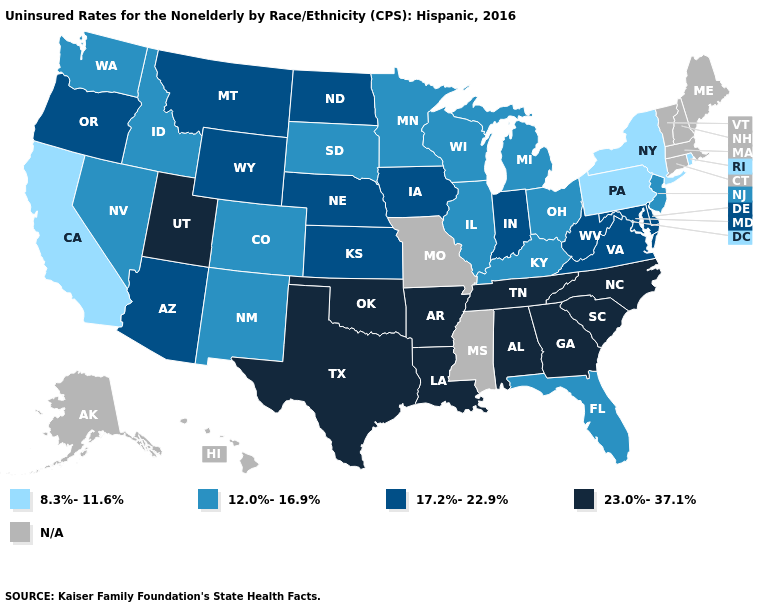Name the states that have a value in the range 23.0%-37.1%?
Answer briefly. Alabama, Arkansas, Georgia, Louisiana, North Carolina, Oklahoma, South Carolina, Tennessee, Texas, Utah. Name the states that have a value in the range 8.3%-11.6%?
Write a very short answer. California, New York, Pennsylvania, Rhode Island. What is the lowest value in states that border Michigan?
Answer briefly. 12.0%-16.9%. Name the states that have a value in the range 17.2%-22.9%?
Concise answer only. Arizona, Delaware, Indiana, Iowa, Kansas, Maryland, Montana, Nebraska, North Dakota, Oregon, Virginia, West Virginia, Wyoming. Name the states that have a value in the range 12.0%-16.9%?
Give a very brief answer. Colorado, Florida, Idaho, Illinois, Kentucky, Michigan, Minnesota, Nevada, New Jersey, New Mexico, Ohio, South Dakota, Washington, Wisconsin. How many symbols are there in the legend?
Concise answer only. 5. What is the value of West Virginia?
Concise answer only. 17.2%-22.9%. Which states have the lowest value in the USA?
Answer briefly. California, New York, Pennsylvania, Rhode Island. What is the lowest value in the USA?
Write a very short answer. 8.3%-11.6%. What is the lowest value in the West?
Concise answer only. 8.3%-11.6%. Does New York have the lowest value in the USA?
Write a very short answer. Yes. Which states have the highest value in the USA?
Be succinct. Alabama, Arkansas, Georgia, Louisiana, North Carolina, Oklahoma, South Carolina, Tennessee, Texas, Utah. What is the value of Texas?
Answer briefly. 23.0%-37.1%. What is the lowest value in the South?
Short answer required. 12.0%-16.9%. Which states have the lowest value in the South?
Answer briefly. Florida, Kentucky. 